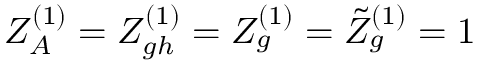Convert formula to latex. <formula><loc_0><loc_0><loc_500><loc_500>Z _ { A } ^ { ( 1 ) } = Z _ { g h } ^ { ( 1 ) } = Z _ { g } ^ { ( 1 ) } = \tilde { Z } _ { g } ^ { ( 1 ) } = 1</formula> 